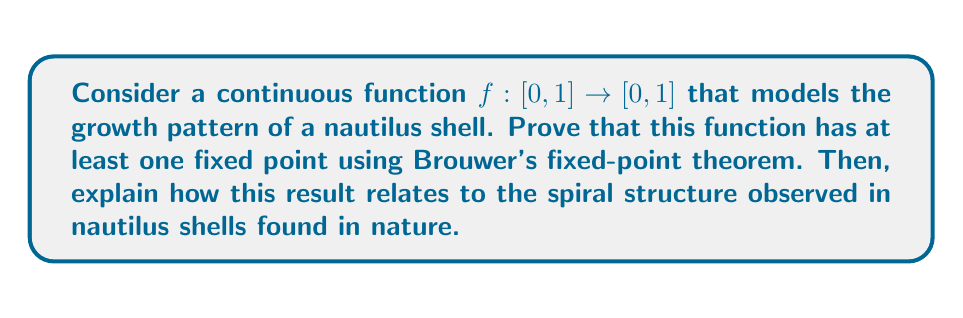Help me with this question. To prove that the function $f$ has at least one fixed point using Brouwer's fixed-point theorem, we'll follow these steps:

1. Recall Brouwer's fixed-point theorem: Any continuous function $f$ from a compact, convex set in a Euclidean space to itself has a fixed point.

2. In our case:
   - The domain and codomain of $f$ is $[0, 1]$, which is a subset of $\mathbb{R}$.
   - $[0, 1]$ is compact (closed and bounded in $\mathbb{R}$).
   - $[0, 1]$ is convex (any line segment between two points in $[0, 1]$ lies entirely within $[0, 1]$).
   - $f$ is continuous (given in the problem statement).

3. Since all conditions of Brouwer's fixed-point theorem are satisfied, we can conclude that $f$ has at least one fixed point. In other words, there exists at least one $x_0 \in [0, 1]$ such that $f(x_0) = x_0$.

Relating this to the spiral structure of nautilus shells:

1. The growth of a nautilus shell can be modeled by a logarithmic spiral, which in polar coordinates is given by the equation:

   $r = ae^{b\theta}$

   where $r$ is the distance from the origin, $\theta$ is the angle, and $a$ and $b$ are constants.

2. The fixed point in our function $f$ corresponds to a point where the growth rate stabilizes, creating the self-similar spiral pattern observed in nautilus shells.

3. This self-similarity is a key feature of the golden ratio ($\phi \approx 1.618$), which is often found in natural growth patterns. The golden ratio can be expressed as the fixed point of the function:

   $g(x) = 1 + \frac{1}{x}$

4. The existence of a fixed point in our growth function ensures that the nautilus shell maintains its characteristic spiral shape as it grows, with each new chamber being proportional to the previous one.

5. This mathematical property reflects the efficiency and beauty of natural growth patterns, where the same basic rules are applied repeatedly to create complex, harmonious structures.

Thus, Brouwer's fixed-point theorem not only proves the existence of a fixed point in our abstract function but also provides insight into the underlying mathematical principles governing the growth and form of nautilus shells in nature.
Answer: The function $f: [0, 1] \rightarrow [0, 1]$ has at least one fixed point, as guaranteed by Brouwer's fixed-point theorem. This fixed point corresponds to a stable growth rate in the nautilus shell's spiral structure, reflecting the self-similar and proportional growth pattern observed in nature. 